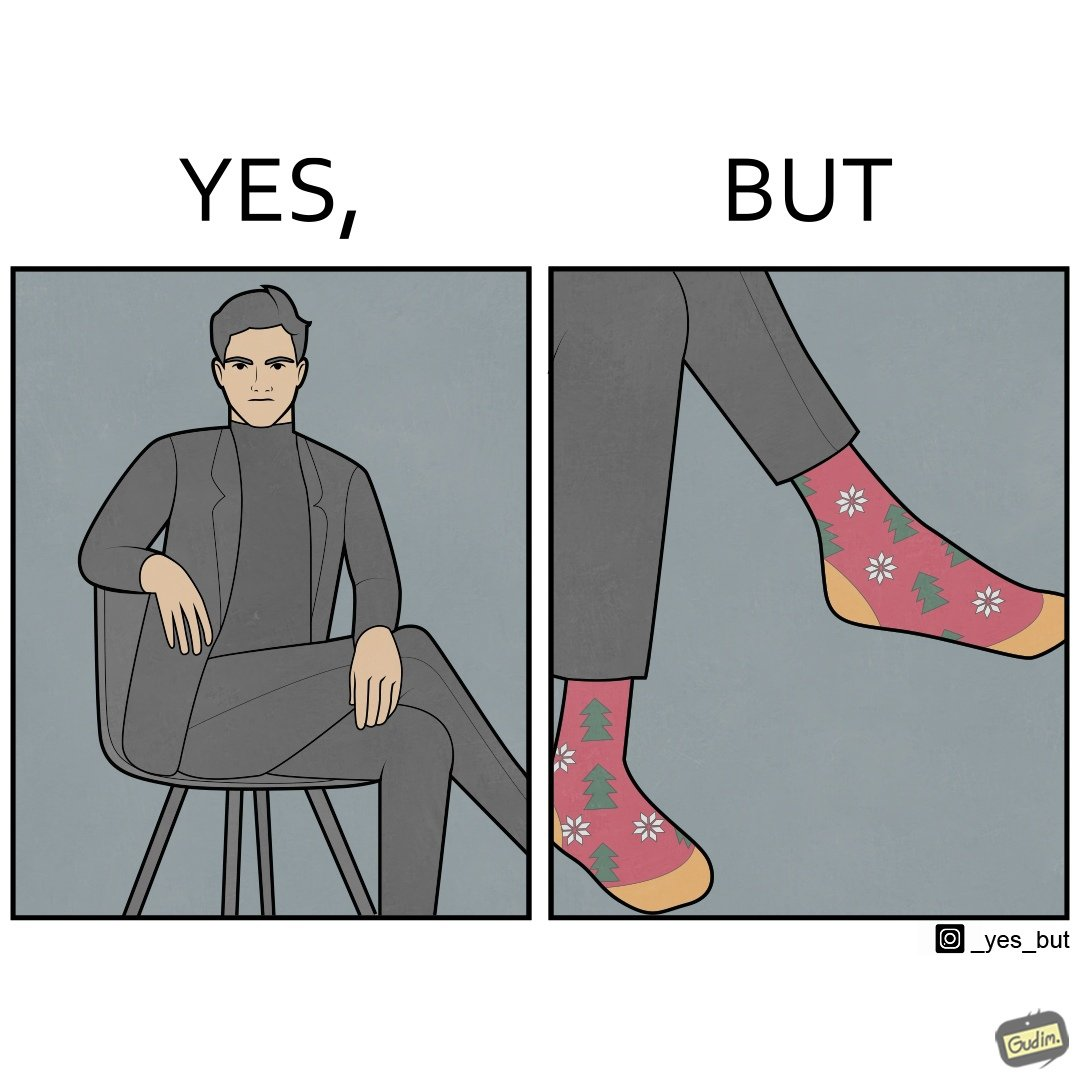Explain the humor or irony in this image. The image is ironical, as the person wearing a formal black suit and pants, is wearing colorful socks, probably due to the reason that socks are not visible while wearing shoes, and hence, do not need to be formal. 